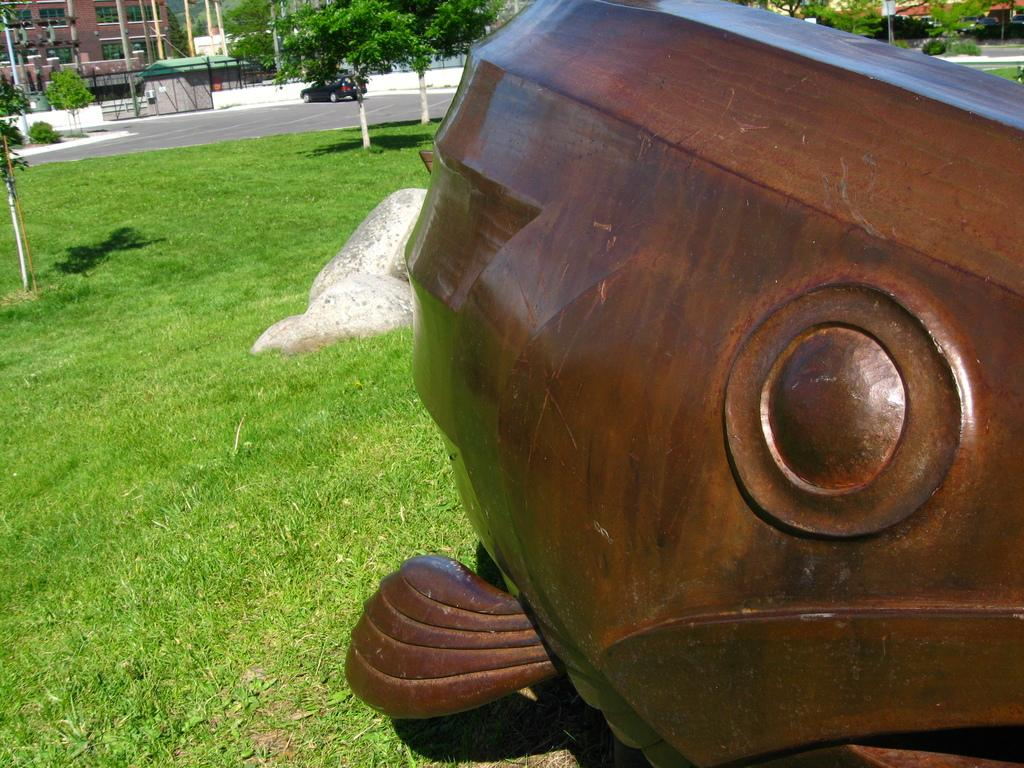What type of object made of wood can be seen in the image? There is a wooden object in the image. What other natural element is present in the image? There is a rock in the image. Where are the wooden object and rock located? The wooden object and rock are on the grass. What structure can be seen at the top of the image? There is a building visible at the top of the image. What man-made object can be seen on the road in the image? There is a car on the road in the image. What type of barrier is present in the image? There is a fence in the image. What type of vegetation is visible in the image? There are trees visible in the image. What type of destruction can be seen happening to the land in the image? There is no destruction visible in the image; it shows a wooden object, a rock, grass, a building, a car, a fence, and trees. What season is depicted in the image? The provided facts do not mention any seasonal details, so it cannot be determined from the image. 